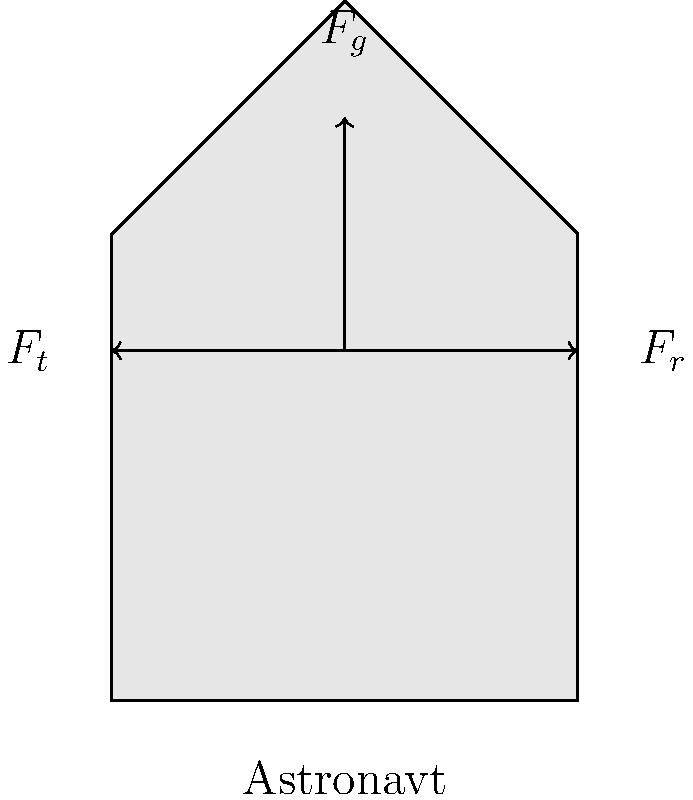Med vesoljskim sprehodom astronavt občuti različne sile. Na diagramu so prikazane tri glavne sile, ki delujejo na astronavta: gravitacijska sila ($F_g$), reakcijska sila ($F_r$) in tenzijska sila ($F_t$). Če predpostavimo, da je astronavt v ravnovesju, kakšna je vsota vseh sil, ki delujejo nanj? Za razumevanje tega problema sledimo naslednjim korakom:

1. Opazimo, da je astronavt v ravnovesju. To pomeni, da nanj ne deluje nobena rezultantna sila.

2. V fiziki velja, da je za telo v ravnovesju vsota vseh sil enaka nič. To zapišemo kot:

   $$\sum \vec{F} = 0$$

3. V našem primeru imamo tri sile:
   - Gravitacijska sila ($\vec{F_g}$), ki deluje navzdol
   - Reakcijska sila ($\vec{F_r}$), ki deluje v desno
   - Tenzijska sila ($\vec{F_t}$), ki deluje v levo

4. Če zapišemo enačbo ravnovesja za te tri sile:

   $$\vec{F_g} + \vec{F_r} + \vec{F_t} = 0$$

5. Ker je vsota teh sil enaka nič, je astronavt v ravnovesju in se ne premika.

6. To stanje je značilno za astronavte med vesoljskim sprehodom, kjer so pritrjeni na vesoljsko plovilo s pomočjo varnostne vrvi, ki ustvarja tenzijsko silo.
Answer: $\sum \vec{F} = 0$ 